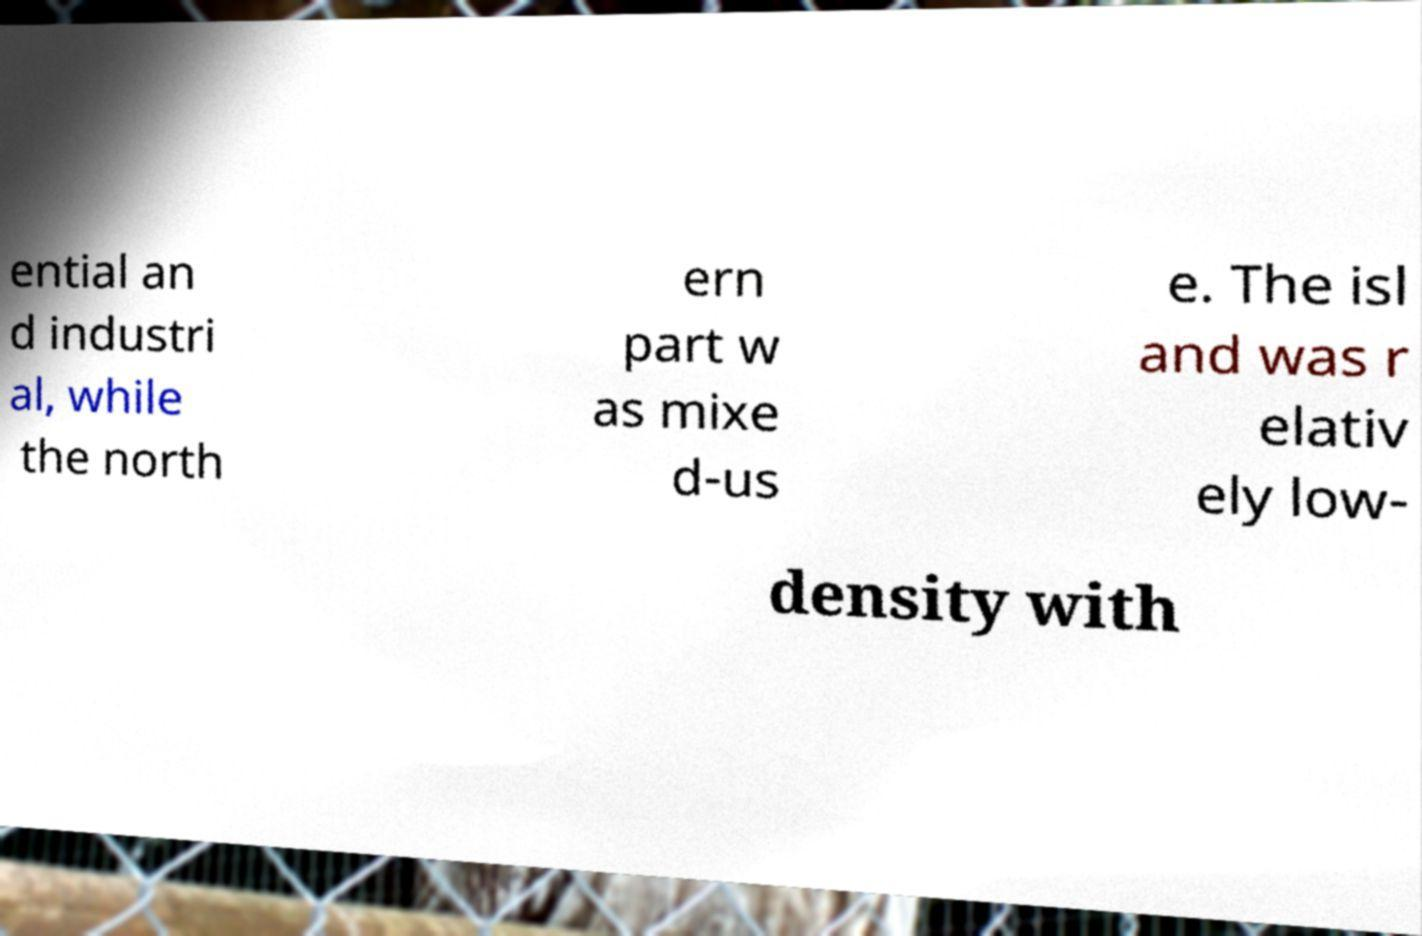I need the written content from this picture converted into text. Can you do that? ential an d industri al, while the north ern part w as mixe d-us e. The isl and was r elativ ely low- density with 